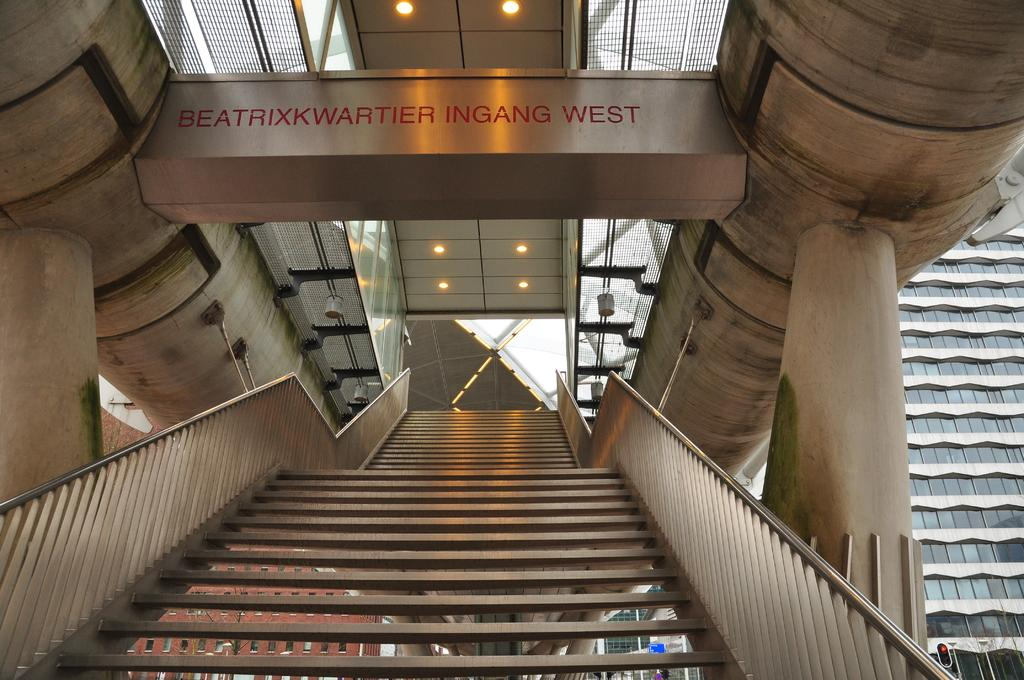What type of location is depicted in the image? The image shows an inside view of a building. What architectural features can be seen in the image? There are pillars visible in the image. What can be used to provide illumination in the image? There are lights in the image. What else can be seen in the image besides the pillars and lights? There are objects present in the image. Can you see any animals from the zoo in the image? There is no zoo or any animals present in the image; it shows an inside view of a building with pillars, lights, and other objects. 